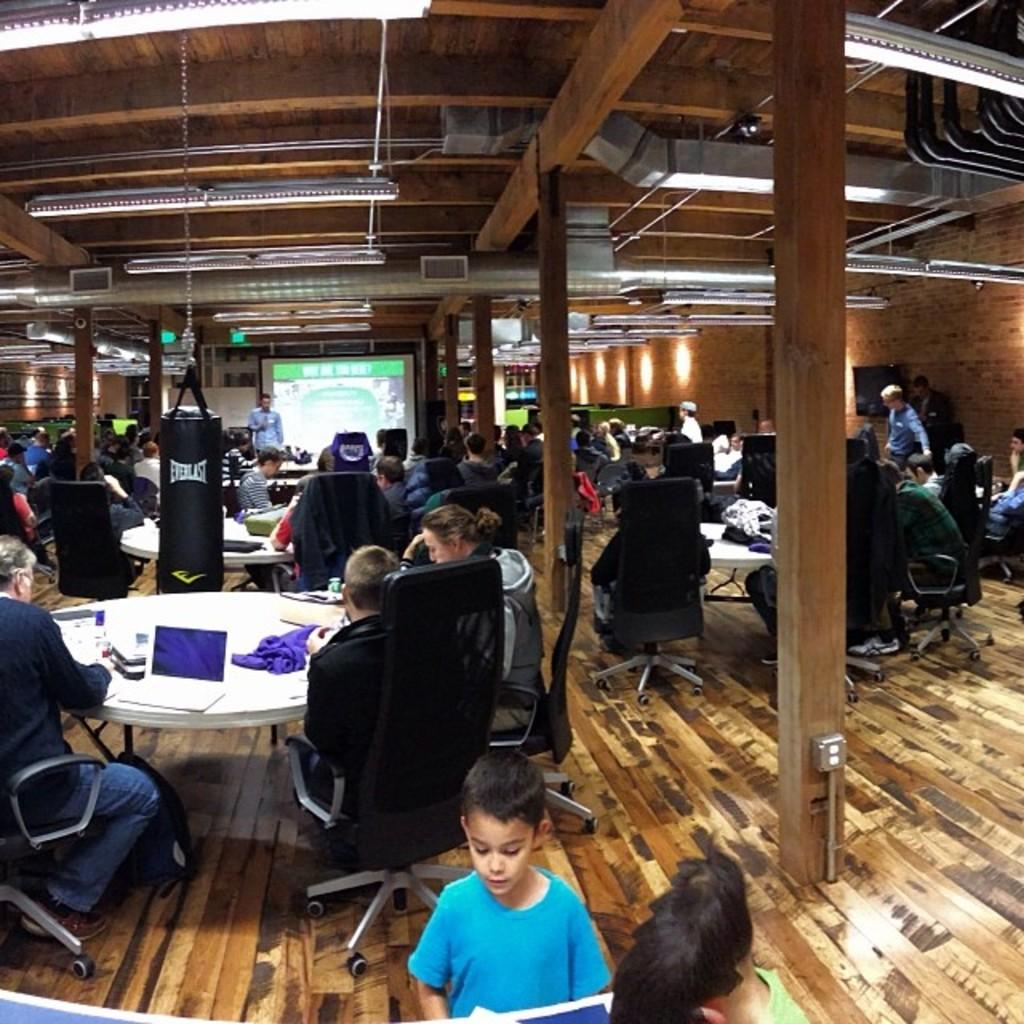What are the people in the image doing? The people in the image are sitting in groups at tables. What is the man doing in the image? The man is presenting. What might the people be listening to the man about? The people are likely listening to the man's presentation. What is located behind the man in the image? There is a screen behind the man. What type of plant is growing on the spoon in the image? There is no plant or spoon present in the image. 